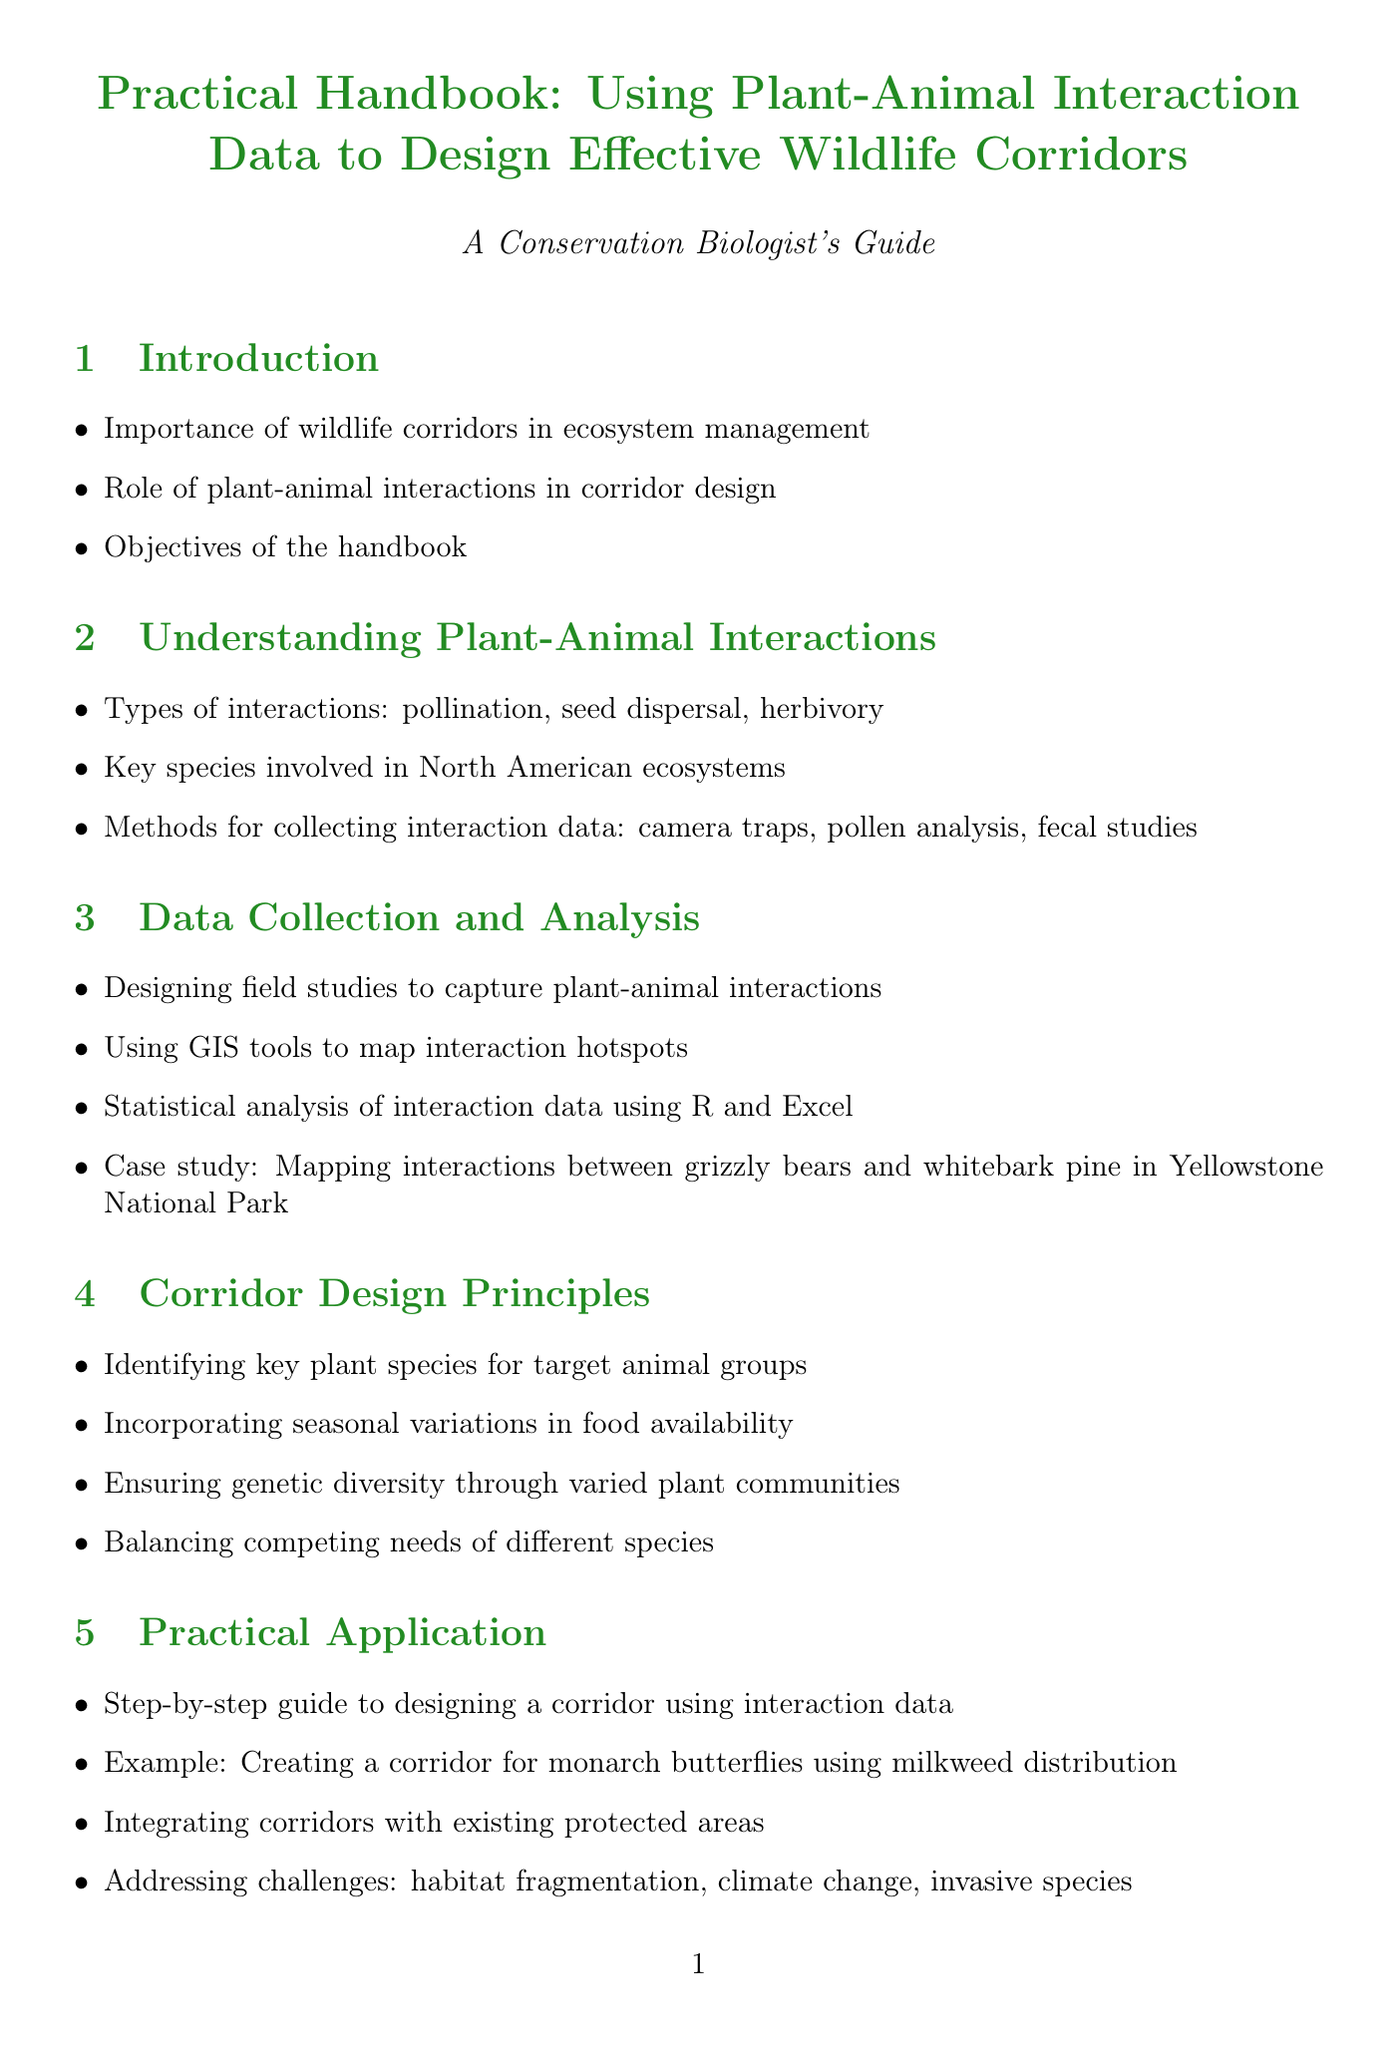What is the main focus of the handbook? The handbook focuses on using plant-animal interaction data to design effective wildlife corridors.
Answer: Designing effective wildlife corridors Which section covers the statistical analysis of interaction data? The section on Data Collection and Analysis details the use of statistical analysis for interaction data.
Answer: Data Collection and Analysis What is one method for collecting interaction data mentioned in the document? The handbook lists methods such as camera traps and pollen analysis for collecting interaction data.
Answer: Camera traps How many case studies are presented in the Case Studies section? The Case Studies section includes four specific examples illustrating successful corridor designs.
Answer: Four What type of interactions does the handbook emphasize for understanding ecosystem dynamics? The handbook highlights interactions including pollination, seed dispersal, and herbivory as vital to ecosystem management.
Answer: Pollination, seed dispersal, herbivory Which animal is referenced in the case study within the Data Collection and Analysis section? The specific case study in the Data Collection section discusses interactions between grizzly bears and whitebark pine.
Answer: Grizzly bears What is a key principle mentioned for corridor design? The handbook states that incorporating seasonal variations in food availability is essential in corridor design.
Answer: Seasonal variations in food availability What type of monitoring does the handbook recommend for corridor effectiveness? The handbook suggests using camera traps and eDNA analysis as monitoring methods for assessing corridor effectiveness.
Answer: Camera traps and eDNA analysis 